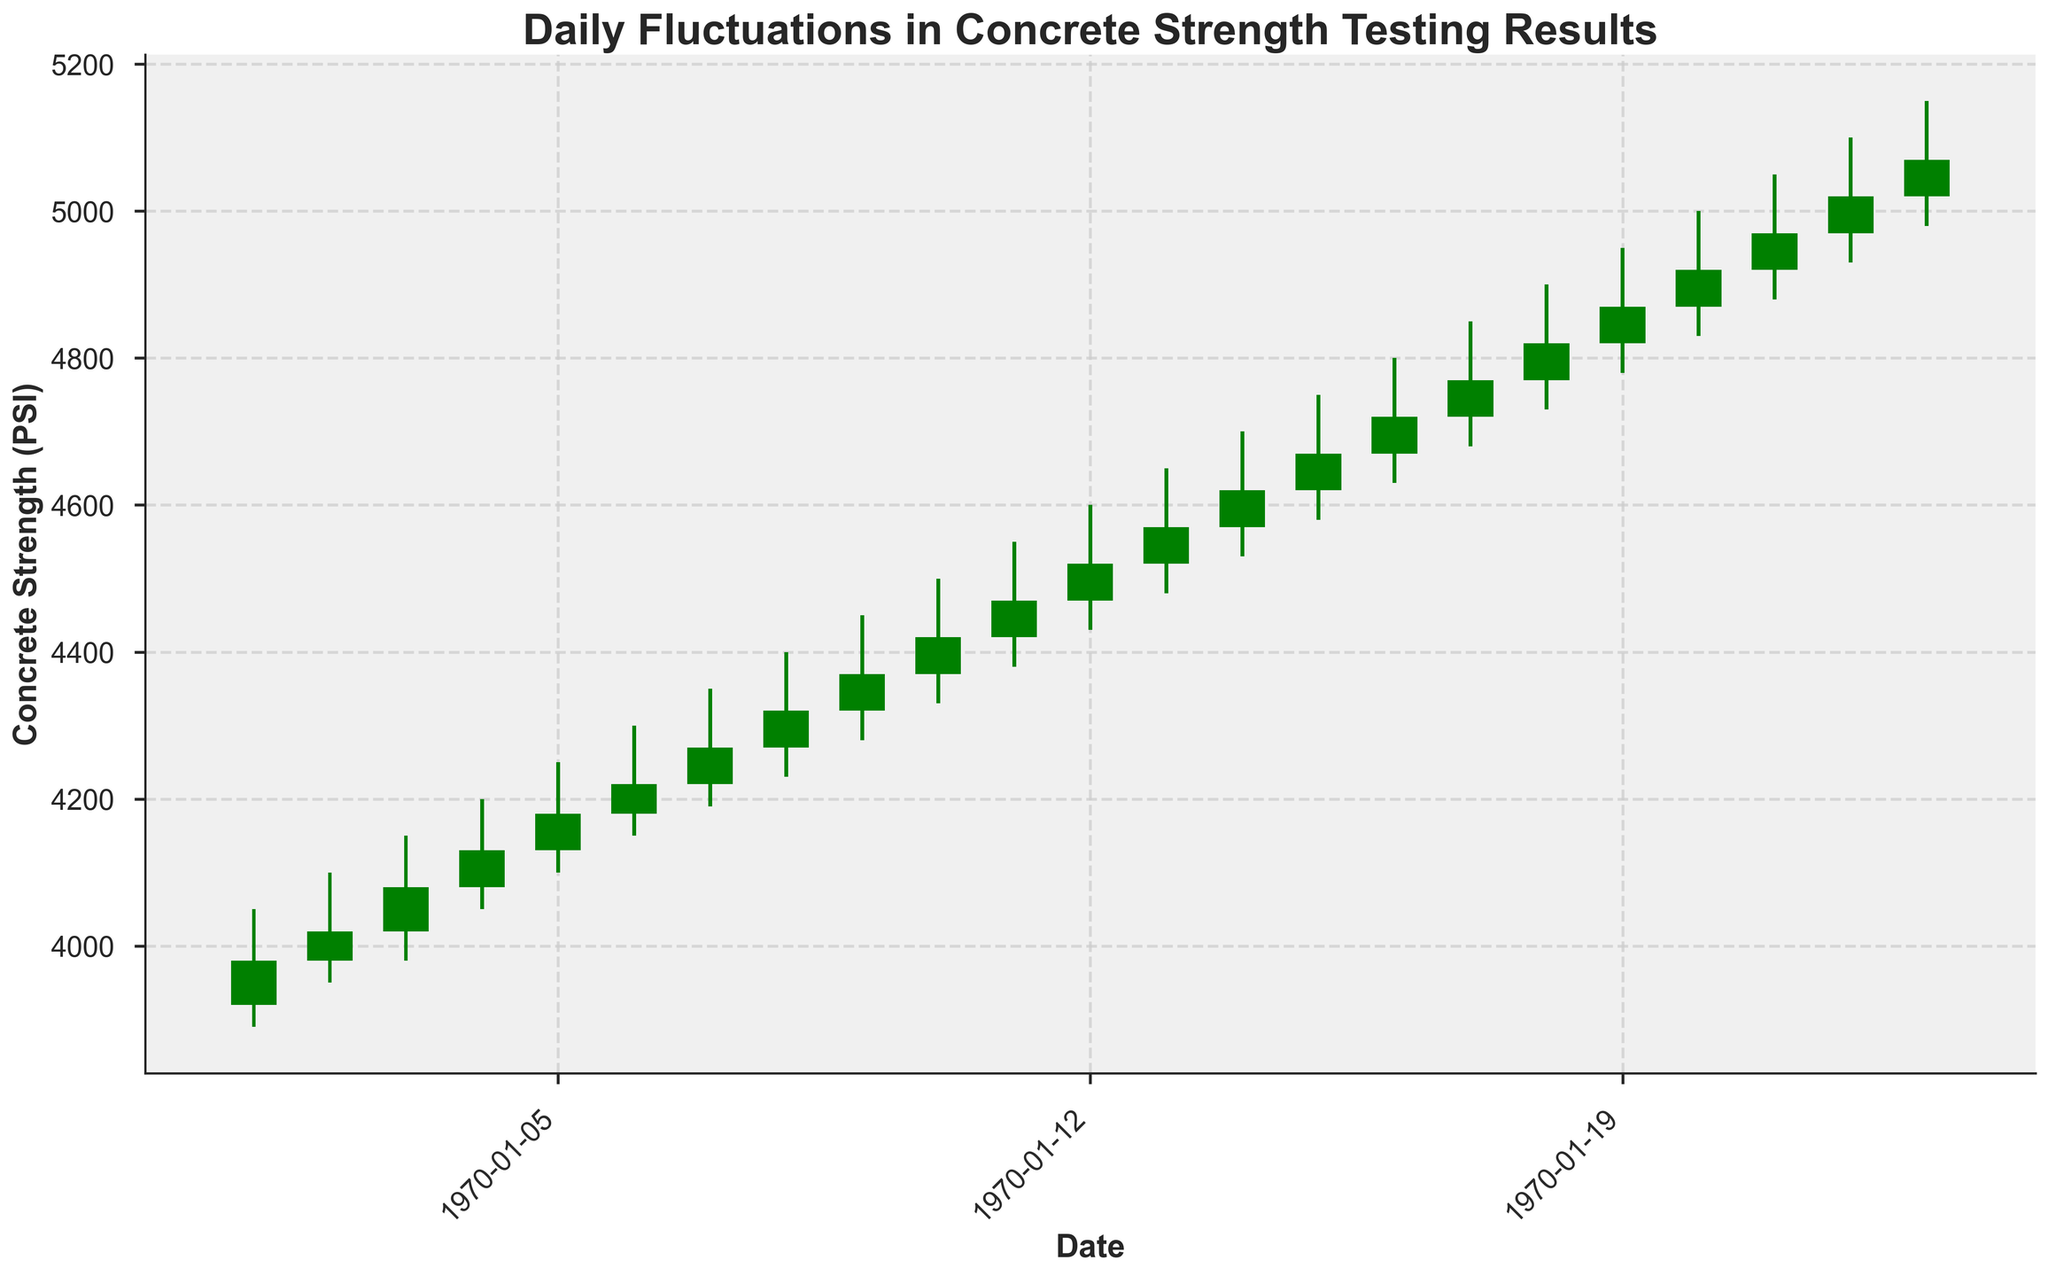What is the title of the figure? The title of the figure is prominently displayed at the top, reflecting the main topic of the chart.
Answer: Daily Fluctuations in Concrete Strength Testing Results How many days of data are presented in the figure? Each bar represents one day, and the x-axis shows all the dates. By counting the dates, we can determine the total number of days.
Answer: 21 What was the highest recorded concrete strength value in the month? The highest recorded value can be found by looking at the highest point in the chart where the "High" bar reaches.
Answer: 5150 PSI On which date did the concrete strength close at its lowest value? By checking the closing values each day and identifying the smallest, we can find the corresponding date on the x-axis.
Answer: 2023-05-01 Which color represents days when the concrete strength increased from open to close? The color of the bars that indicate an increase from open to close can be identified by the consistent coloring pattern.
Answer: Green How many times did the concrete strength close higher than the opening this month? By counting all the green colored bars, which represent days when the close value is higher than the opening value.
Answer: 21 Which date saw the highest range between the low and high values? The range can be calculated by subtracting the low value from the high value for each date and identifying the largest difference. The figure will help in spotting the dates visually first.
Answer: 2023-05-31 How does the closing value on May 10 compare with that on May 20? By checking the closing values for both dates in the figure and comparing them directly to see which is higher or lower.
Answer: May 10 is lower than May 20 Which day saw the largest decrease in concrete strength from the opening to the closing value? By observing the red bars, which show days where the strength decreased, and identifying the bar with the largest difference between the open and close values visually.
Answer: No day saw a decrease, as all bars are green What is the average closing value for the entire month? Sum all the closing values and divide by the total number of days to find the average. Here we sum the given daily closing values and then divide by 21.
Answer: (3980 + 4020 + 4080 + 4130 + 4180 + 4220 + 4270 + 4320 + 4370 + 4420 + 4470 + 4520 + 4570 + 4620 + 4670 + 4720 + 4770 + 4820 + 4870 + 4920 + 4970 + 5020 + 5070) / 21 = 4519.52 PSI 